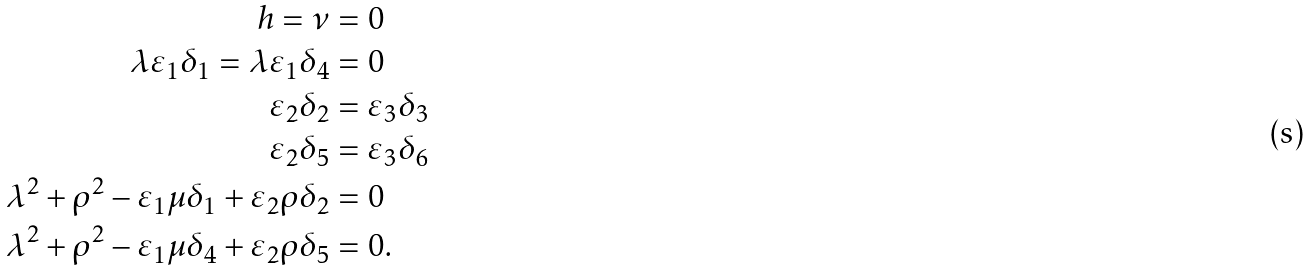<formula> <loc_0><loc_0><loc_500><loc_500>h = \nu & = 0 \\ \lambda \varepsilon _ { 1 } \delta _ { 1 } = \lambda \varepsilon _ { 1 } \delta _ { 4 } & = 0 \\ \varepsilon _ { 2 } \delta _ { 2 } & = \varepsilon _ { 3 } \delta _ { 3 } \\ \varepsilon _ { 2 } \delta _ { 5 } & = \varepsilon _ { 3 } \delta _ { 6 } \\ \lambda ^ { 2 } + \rho ^ { 2 } - \varepsilon _ { 1 } \mu \delta _ { 1 } + \varepsilon _ { 2 } \rho \delta _ { 2 } & = 0 \\ \lambda ^ { 2 } + \rho ^ { 2 } - \varepsilon _ { 1 } \mu \delta _ { 4 } + \varepsilon _ { 2 } \rho \delta _ { 5 } & = 0 .</formula> 